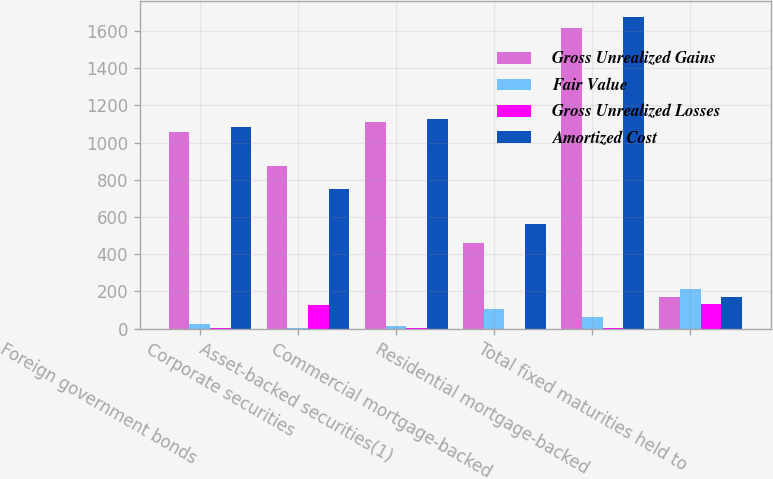Convert chart to OTSL. <chart><loc_0><loc_0><loc_500><loc_500><stacked_bar_chart><ecel><fcel>Foreign government bonds<fcel>Corporate securities<fcel>Asset-backed securities(1)<fcel>Commercial mortgage-backed<fcel>Residential mortgage-backed<fcel>Total fixed maturities held to<nl><fcel>Gross Unrealized Gains<fcel>1058<fcel>876<fcel>1112<fcel>460<fcel>1614<fcel>172<nl><fcel>Fair Value<fcel>25<fcel>1<fcel>16<fcel>104<fcel>65<fcel>211<nl><fcel>Gross Unrealized Losses<fcel>1<fcel>126<fcel>3<fcel>0<fcel>3<fcel>133<nl><fcel>Amortized Cost<fcel>1082<fcel>751<fcel>1125<fcel>564<fcel>1676<fcel>172<nl></chart> 